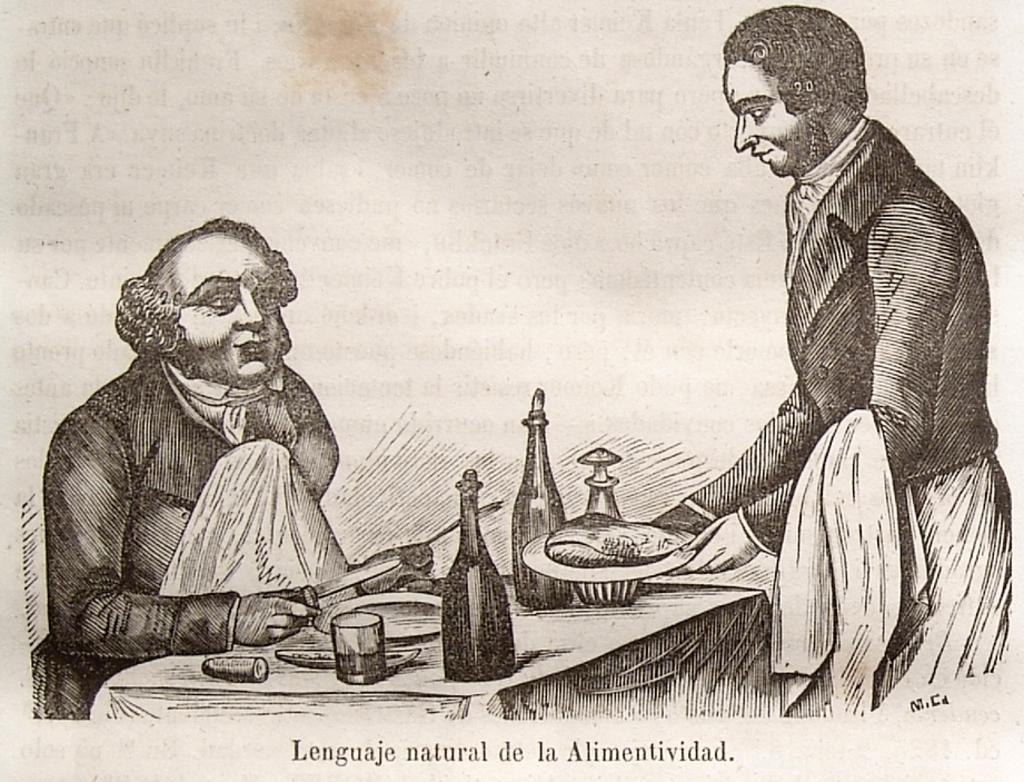Please provide a concise description of this image. In this image there is a painting of a person serving food to another person in front of him. On the table there are bottles, glasses, plates, knives. At the bottom of the image there is some text written. 